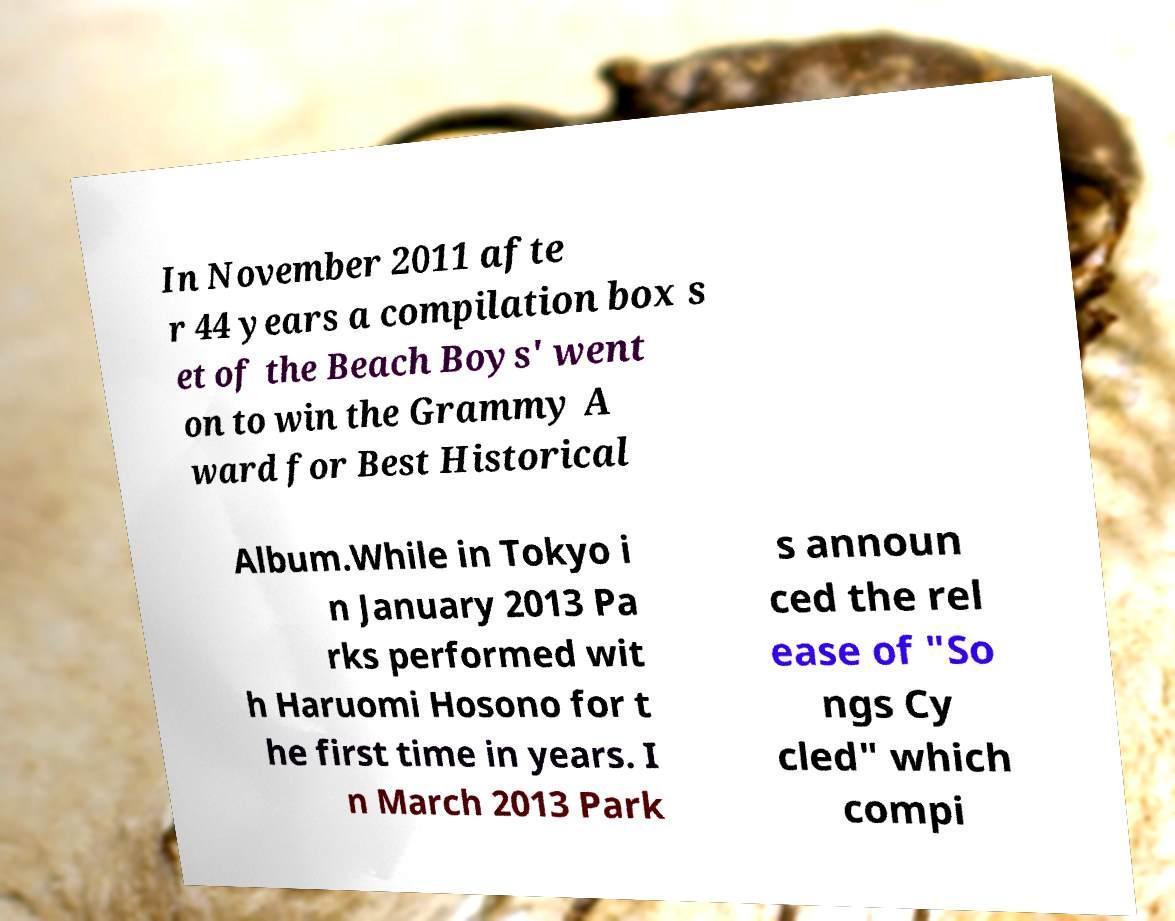Please read and relay the text visible in this image. What does it say? In November 2011 afte r 44 years a compilation box s et of the Beach Boys' went on to win the Grammy A ward for Best Historical Album.While in Tokyo i n January 2013 Pa rks performed wit h Haruomi Hosono for t he first time in years. I n March 2013 Park s announ ced the rel ease of "So ngs Cy cled" which compi 